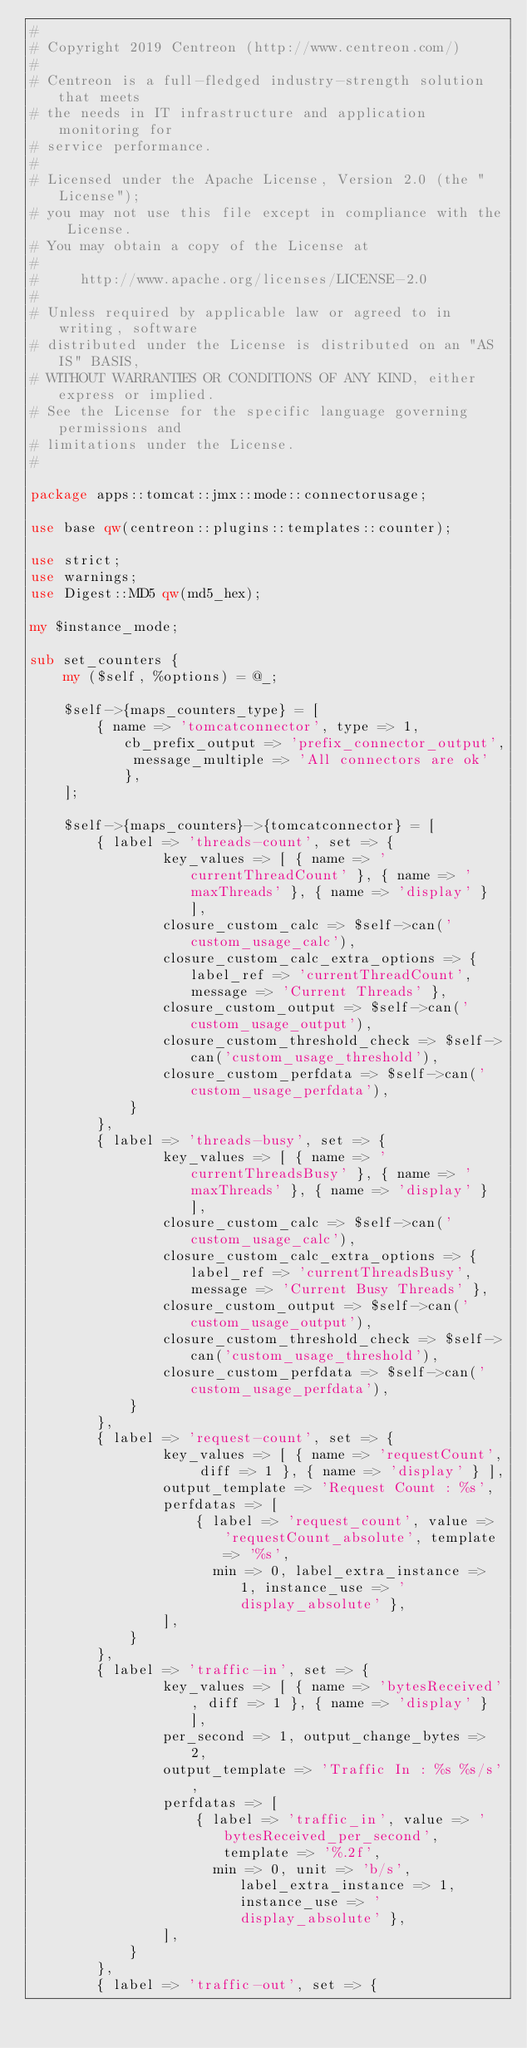Convert code to text. <code><loc_0><loc_0><loc_500><loc_500><_Perl_>#
# Copyright 2019 Centreon (http://www.centreon.com/)
#
# Centreon is a full-fledged industry-strength solution that meets
# the needs in IT infrastructure and application monitoring for
# service performance.
#
# Licensed under the Apache License, Version 2.0 (the "License");
# you may not use this file except in compliance with the License.
# You may obtain a copy of the License at
#
#     http://www.apache.org/licenses/LICENSE-2.0
#
# Unless required by applicable law or agreed to in writing, software
# distributed under the License is distributed on an "AS IS" BASIS,
# WITHOUT WARRANTIES OR CONDITIONS OF ANY KIND, either express or implied.
# See the License for the specific language governing permissions and
# limitations under the License.
#

package apps::tomcat::jmx::mode::connectorusage;

use base qw(centreon::plugins::templates::counter);

use strict;
use warnings;
use Digest::MD5 qw(md5_hex);

my $instance_mode;

sub set_counters {
    my ($self, %options) = @_;

    $self->{maps_counters_type} = [
        { name => 'tomcatconnector', type => 1, cb_prefix_output => 'prefix_connector_output', message_multiple => 'All connectors are ok' },
    ];
    
    $self->{maps_counters}->{tomcatconnector} = [
        { label => 'threads-count', set => {
                key_values => [ { name => 'currentThreadCount' }, { name => 'maxThreads' }, { name => 'display' } ],
                closure_custom_calc => $self->can('custom_usage_calc'), 
                closure_custom_calc_extra_options => { label_ref => 'currentThreadCount', message => 'Current Threads' },
                closure_custom_output => $self->can('custom_usage_output'),
                closure_custom_threshold_check => $self->can('custom_usage_threshold'),
                closure_custom_perfdata => $self->can('custom_usage_perfdata'),
            }
        },
        { label => 'threads-busy', set => {
                key_values => [ { name => 'currentThreadsBusy' }, { name => 'maxThreads' }, { name => 'display' } ],
                closure_custom_calc => $self->can('custom_usage_calc'), 
                closure_custom_calc_extra_options => { label_ref => 'currentThreadsBusy', message => 'Current Busy Threads' },
                closure_custom_output => $self->can('custom_usage_output'),
                closure_custom_threshold_check => $self->can('custom_usage_threshold'),
                closure_custom_perfdata => $self->can('custom_usage_perfdata'),
            }
        },
        { label => 'request-count', set => {
                key_values => [ { name => 'requestCount', diff => 1 }, { name => 'display' } ],
                output_template => 'Request Count : %s',
                perfdatas => [
                    { label => 'request_count', value => 'requestCount_absolute', template => '%s',
                      min => 0, label_extra_instance => 1, instance_use => 'display_absolute' },
                ],
            }
        },
        { label => 'traffic-in', set => {
                key_values => [ { name => 'bytesReceived', diff => 1 }, { name => 'display' } ],
                per_second => 1, output_change_bytes => 2,
                output_template => 'Traffic In : %s %s/s',
                perfdatas => [
                    { label => 'traffic_in', value => 'bytesReceived_per_second', template => '%.2f',
                      min => 0, unit => 'b/s', label_extra_instance => 1, instance_use => 'display_absolute' },
                ],
            }
        },
        { label => 'traffic-out', set => {</code> 